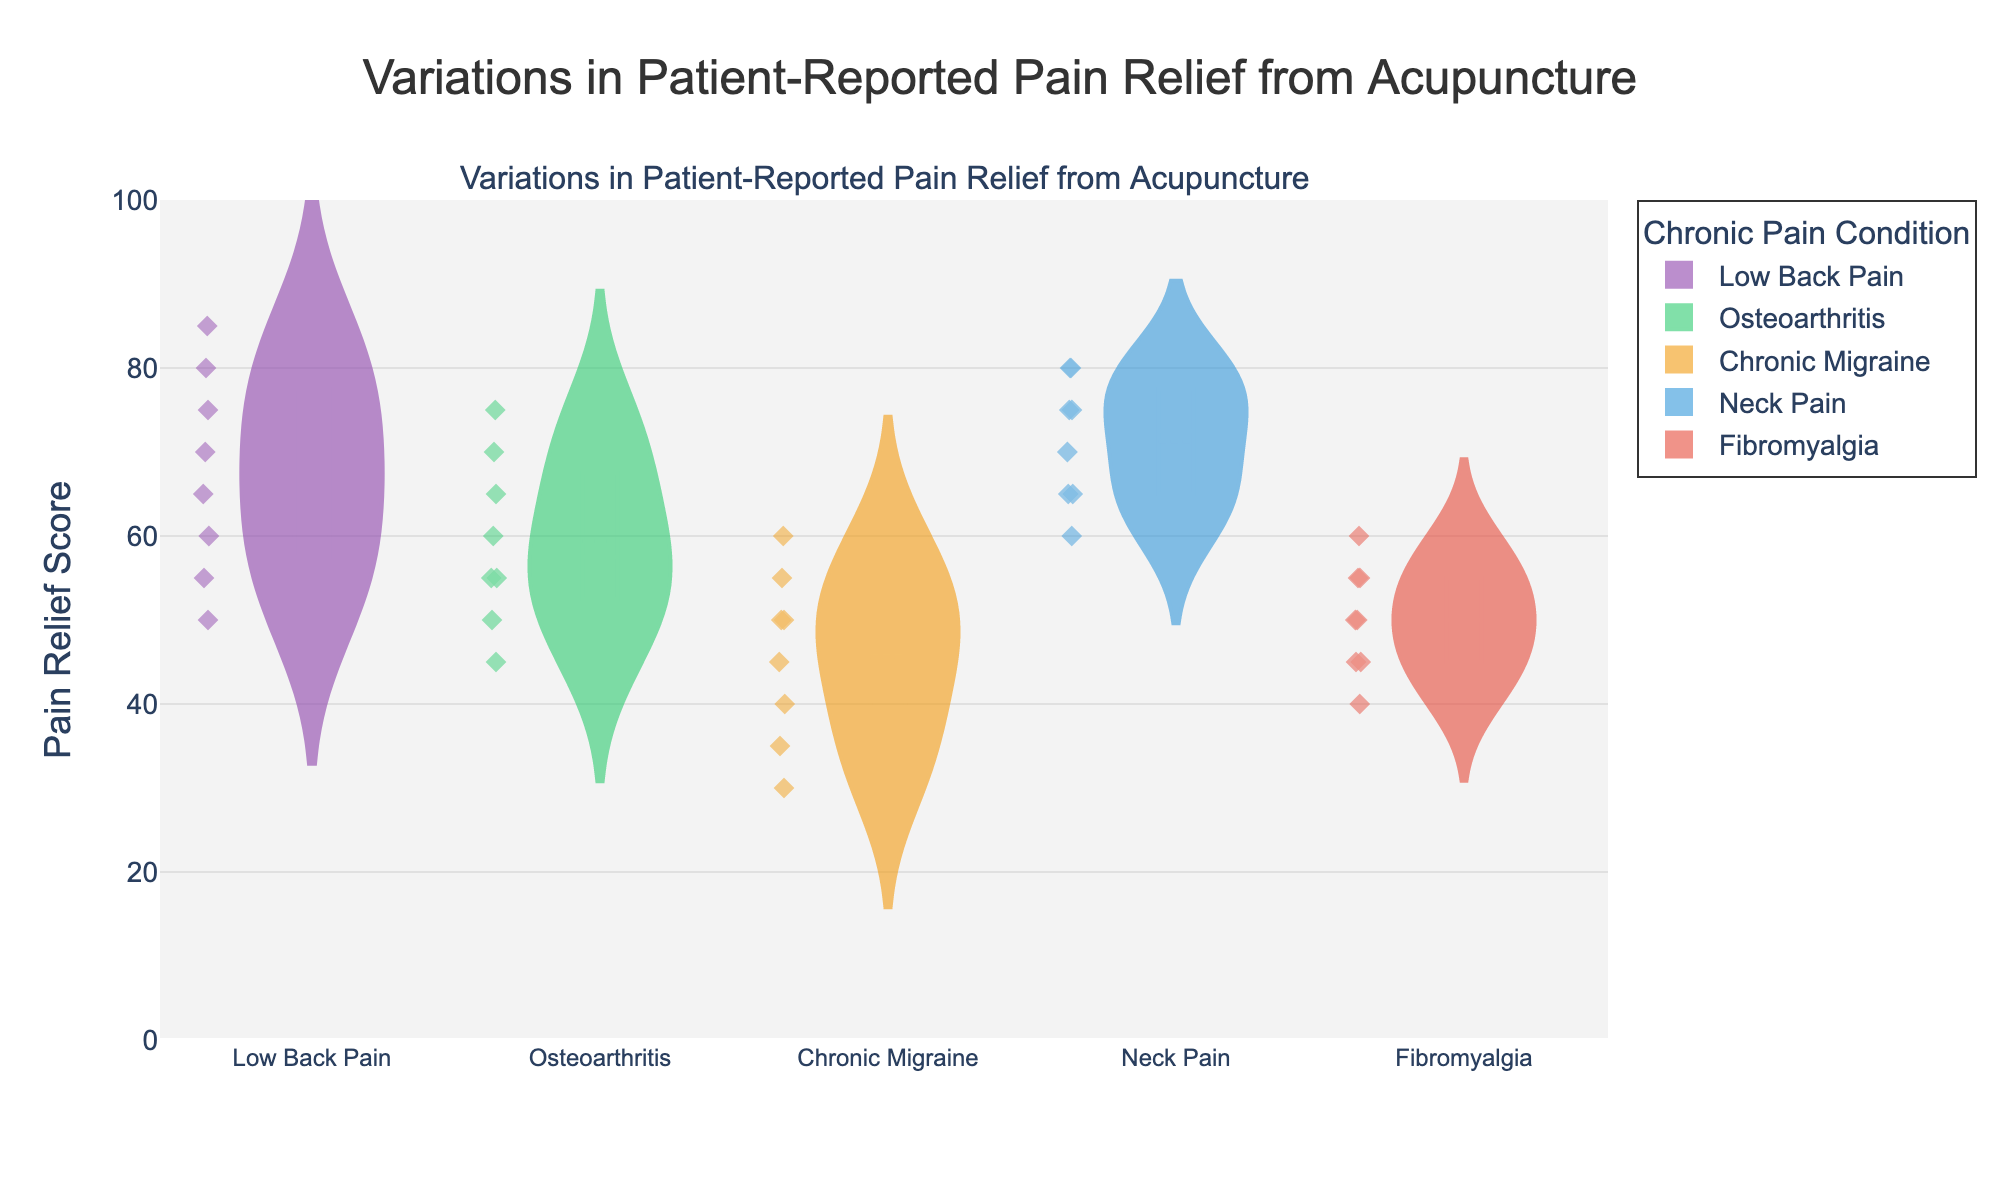What is the title of the figure? The title is located at the top center of the figure in larger font size and typically summarizes the main focus of the chart. From the provided data and code, the title is "Variations in Patient-Reported Pain Relief from Acupuncture."
Answer: Variations in Patient-Reported Pain Relief from Acupuncture How many chronic pain conditions are represented in the figure? Each unique chronic pain condition has a violin chart, and the provided data lists five unique conditions: Low Back Pain, Osteoarthritis, Chronic Migraine, Neck Pain, and Fibromyalgia.
Answer: 5 Which chronic pain condition shows the highest median pain relief score? The median pain relief score can be observed from the centerline of each violin plot. By examining the plots, the condition with the highest centerline is identified.
Answer: Neck Pain What is the range of pain relief scores for Low Back Pain? The range of the pain relief scores for Low Back Pain can be observed from the top and bottom ends of its violin plot. These are the maximum and minimum values within the violin plot.
Answer: 50-85 Which chronic pain condition has the most variability in pain relief scores? The variability can be judged by the width and spread of the violin plot. The condition with the widest and most spread-out plot has the highest variability.
Answer: Fibromyalgia Compare the mean pain relief scores of Chronic Migraine and Osteoarthritis. Which one is higher? The mean pain relief score is indicated by a line within the violin plot. Comparing the lines of Chronic Migraine and Osteoarthritis shows which one is higher.
Answer: Osteoarthritis For which chronic pain condition do all pain relief scores fall between 40 and 60? By observing the extremities of the violin plots, identify which condition's violin plot falls entirely within the 40-60 range on the y-axis.
Answer: Chronic Migraine How does the pain relief score for Neck Pain at the 75th percentile compare to Low Back Pain? Percentiles are represented by the spread of data within the violin plot. The 75th percentile is around the upper quarter of the plot. Compare the positions in Neck Pain and Low Back Pain.
Answer: Neck Pain is higher What is the primary color used to represent Osteoarthritis in the figure? Each chronic pain condition is associated with a specific color. By identifying the color used in the provided code for Osteoarthritis, we can determine this.
Answer: Green What can be inferred about the treatment effectiveness of acupuncture for Low Back Pain versus Fibromyalgia based on the figure? Evaluating factors like median, range, and variability within each violin plot provides insights into the effectiveness. Comparing these elements for Low Back Pain and Fibromyalgia suggests the differences.
Answer: Acupuncture appears more effective for Low Back Pain due to higher median scores and less variability 